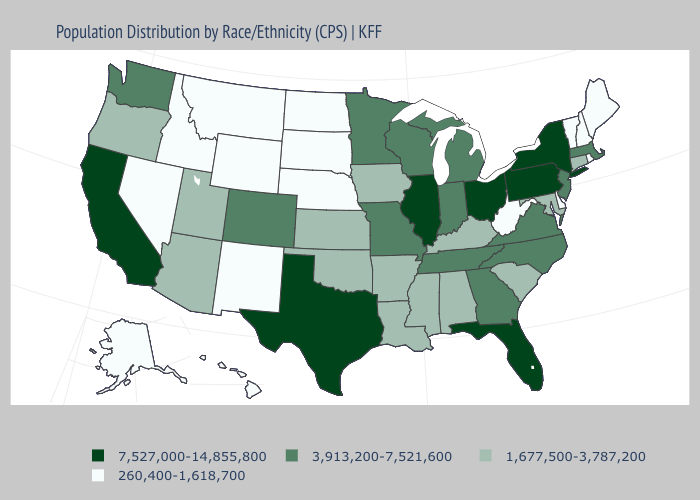Does the map have missing data?
Quick response, please. No. Name the states that have a value in the range 1,677,500-3,787,200?
Quick response, please. Alabama, Arizona, Arkansas, Connecticut, Iowa, Kansas, Kentucky, Louisiana, Maryland, Mississippi, Oklahoma, Oregon, South Carolina, Utah. What is the lowest value in the USA?
Be succinct. 260,400-1,618,700. Does Vermont have the lowest value in the Northeast?
Be succinct. Yes. Does West Virginia have the highest value in the USA?
Short answer required. No. Which states hav the highest value in the Northeast?
Keep it brief. New York, Pennsylvania. Among the states that border Georgia , which have the highest value?
Quick response, please. Florida. What is the value of Wisconsin?
Give a very brief answer. 3,913,200-7,521,600. Is the legend a continuous bar?
Concise answer only. No. What is the value of Massachusetts?
Write a very short answer. 3,913,200-7,521,600. What is the value of Massachusetts?
Short answer required. 3,913,200-7,521,600. Name the states that have a value in the range 3,913,200-7,521,600?
Give a very brief answer. Colorado, Georgia, Indiana, Massachusetts, Michigan, Minnesota, Missouri, New Jersey, North Carolina, Tennessee, Virginia, Washington, Wisconsin. Name the states that have a value in the range 1,677,500-3,787,200?
Short answer required. Alabama, Arizona, Arkansas, Connecticut, Iowa, Kansas, Kentucky, Louisiana, Maryland, Mississippi, Oklahoma, Oregon, South Carolina, Utah. Which states have the highest value in the USA?
Short answer required. California, Florida, Illinois, New York, Ohio, Pennsylvania, Texas. Does the first symbol in the legend represent the smallest category?
Concise answer only. No. 